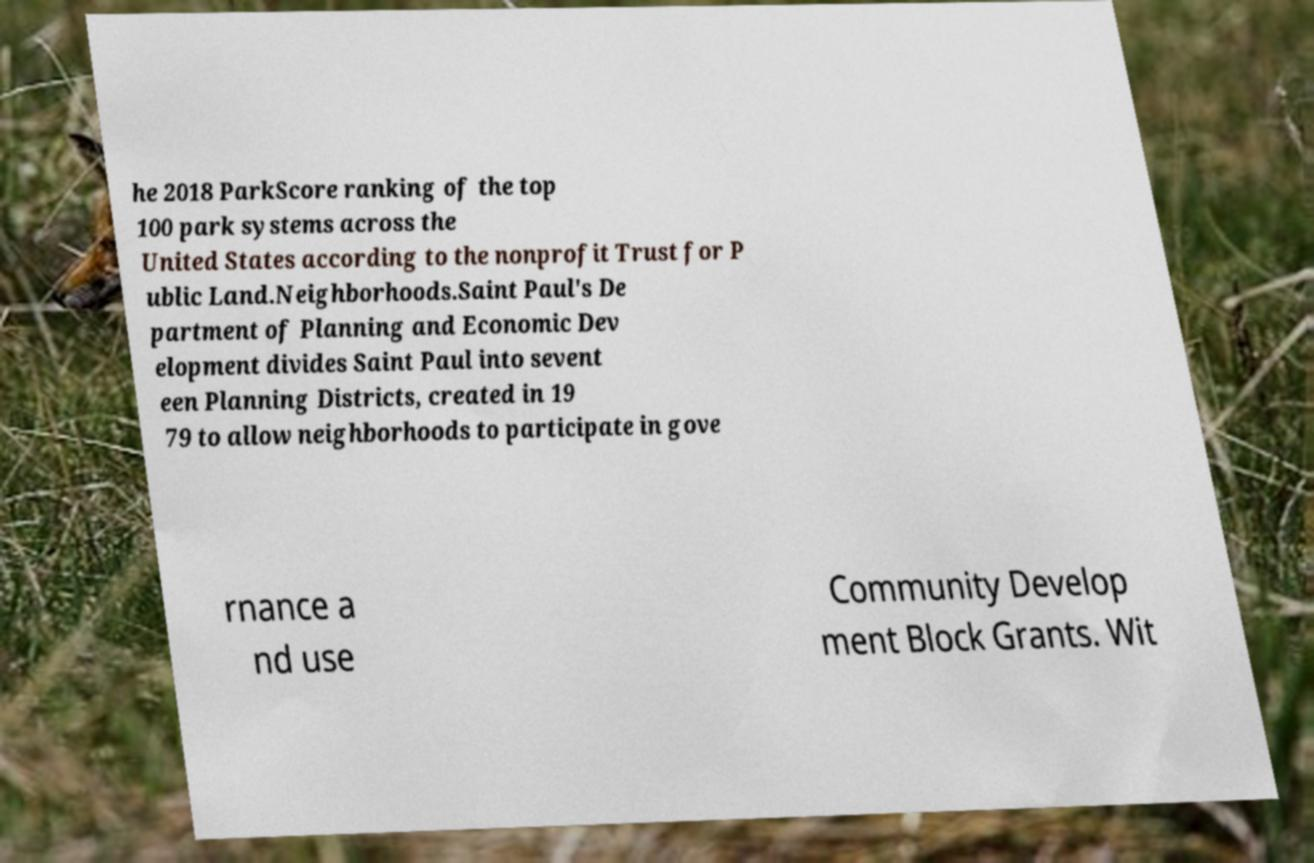Could you assist in decoding the text presented in this image and type it out clearly? he 2018 ParkScore ranking of the top 100 park systems across the United States according to the nonprofit Trust for P ublic Land.Neighborhoods.Saint Paul's De partment of Planning and Economic Dev elopment divides Saint Paul into sevent een Planning Districts, created in 19 79 to allow neighborhoods to participate in gove rnance a nd use Community Develop ment Block Grants. Wit 